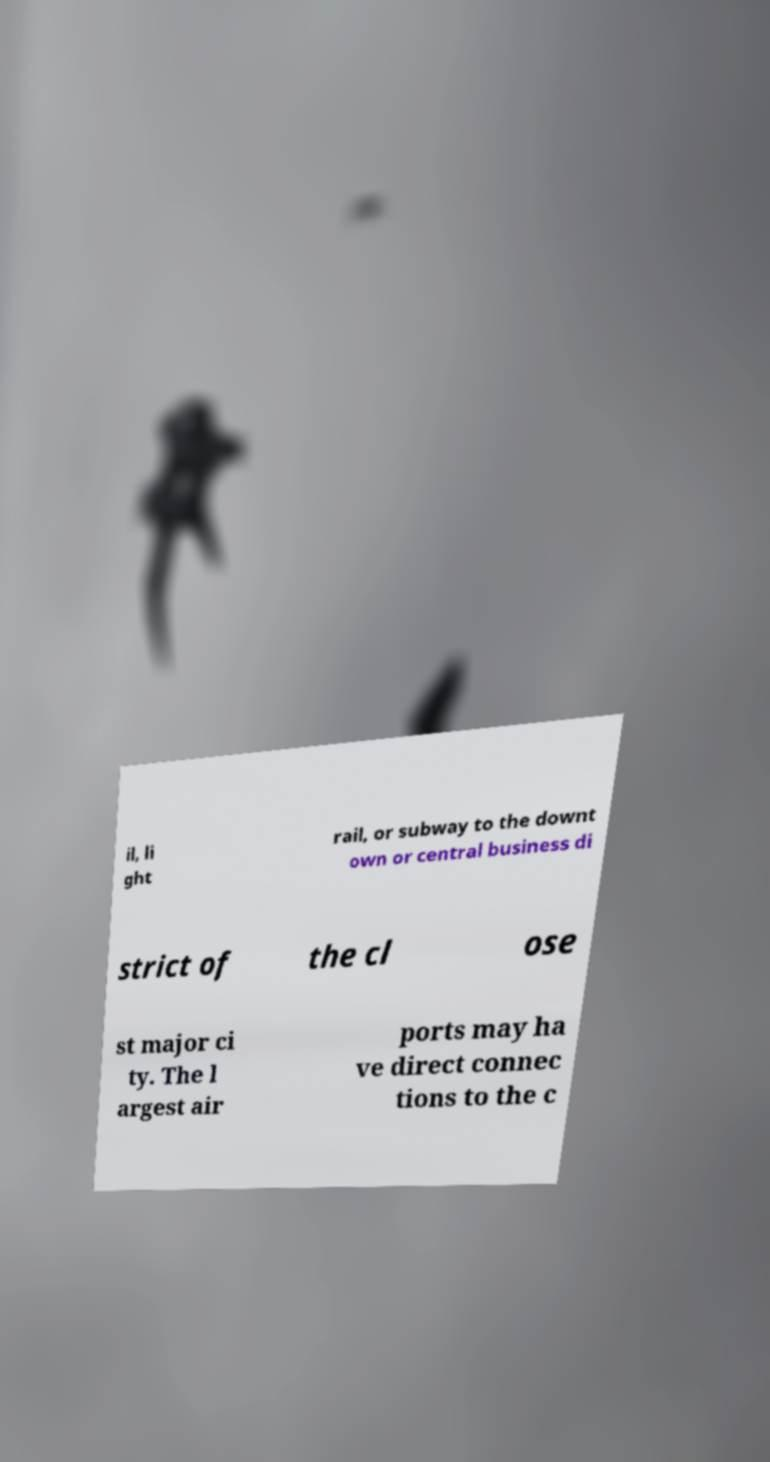Please read and relay the text visible in this image. What does it say? il, li ght rail, or subway to the downt own or central business di strict of the cl ose st major ci ty. The l argest air ports may ha ve direct connec tions to the c 